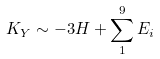<formula> <loc_0><loc_0><loc_500><loc_500>K _ { Y } \sim - 3 H + \sum _ { 1 } ^ { 9 } E _ { i }</formula> 